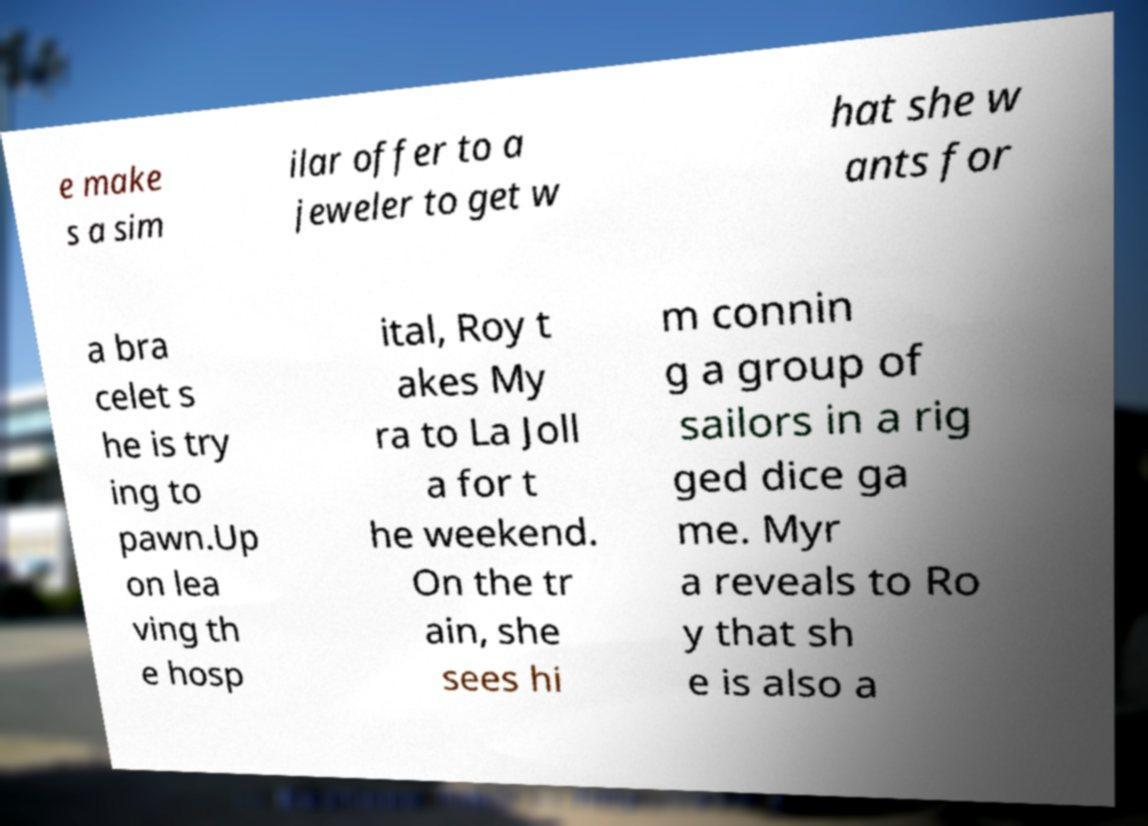Please read and relay the text visible in this image. What does it say? e make s a sim ilar offer to a jeweler to get w hat she w ants for a bra celet s he is try ing to pawn.Up on lea ving th e hosp ital, Roy t akes My ra to La Joll a for t he weekend. On the tr ain, she sees hi m connin g a group of sailors in a rig ged dice ga me. Myr a reveals to Ro y that sh e is also a 